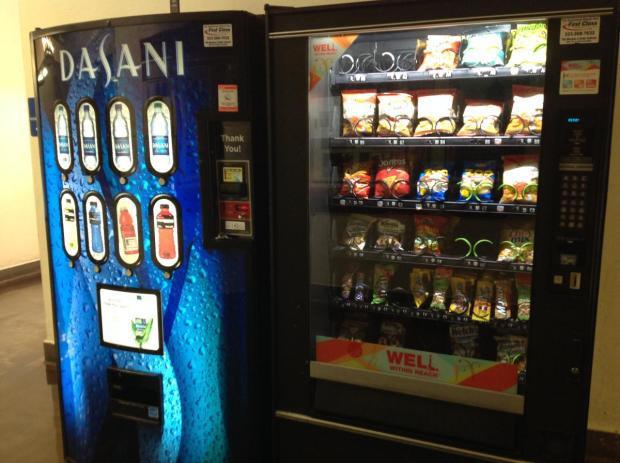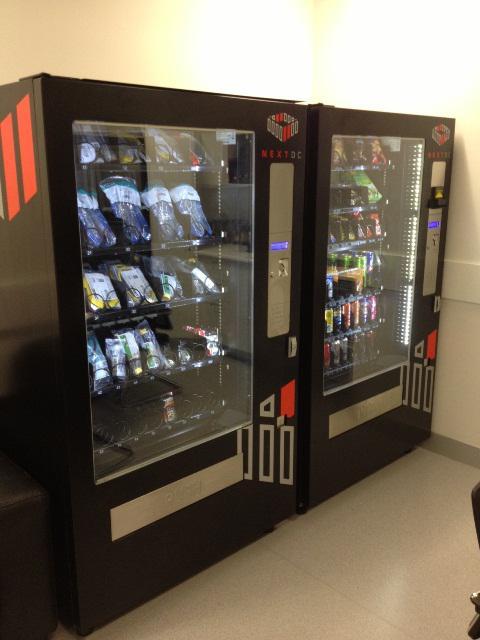The first image is the image on the left, the second image is the image on the right. For the images shown, is this caption "At least one beverage vending machine has a blue 'wet look' front." true? Answer yes or no. Yes. The first image is the image on the left, the second image is the image on the right. Examine the images to the left and right. Is the description "The left image contains at least one vending machine that is mostly blue in color." accurate? Answer yes or no. Yes. 